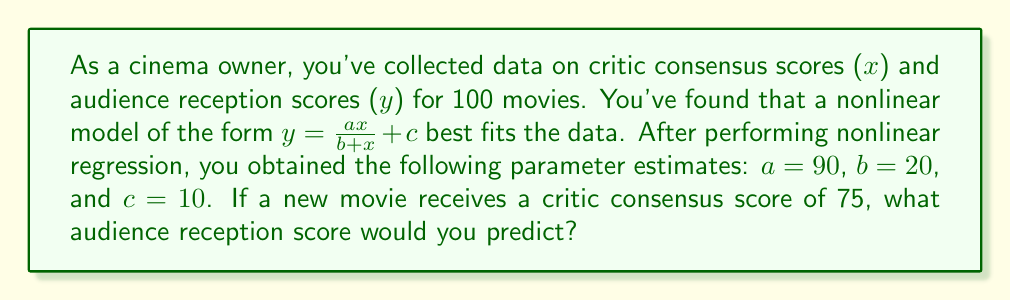Show me your answer to this math problem. To solve this problem, we'll follow these steps:

1) We have the nonlinear model: $y = \frac{ax}{b+x} + c$

2) The parameter estimates are:
   $a = 90$
   $b = 20$
   $c = 10$

3) We need to predict y when x = 75. Let's substitute these values into our equation:

   $y = \frac{90 \cdot 75}{20 + 75} + 10$

4) Simplify the numerator:
   $y = \frac{6750}{20 + 75} + 10$

5) Simplify the denominator:
   $y = \frac{6750}{95} + 10$

6) Divide:
   $y = 71.05263158 + 10$

7) Add:
   $y = 81.05263158$

8) Round to two decimal places for a reasonable prediction:
   $y \approx 81.05$

Therefore, for a critic consensus score of 75, we would predict an audience reception score of approximately 81.05.
Answer: 81.05 